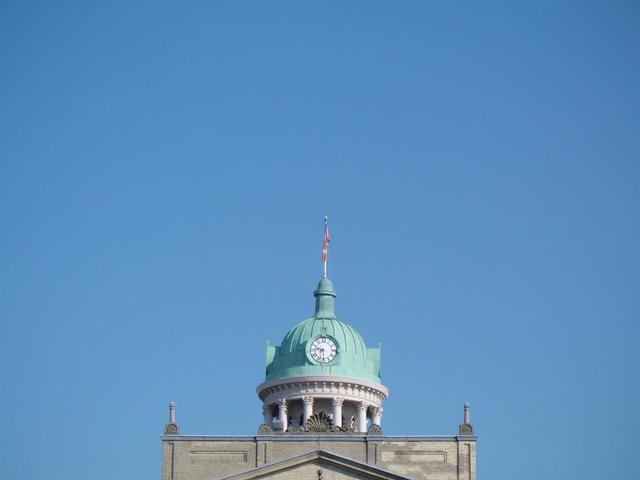How many people are visible behind the man seated in blue?
Give a very brief answer. 0. 